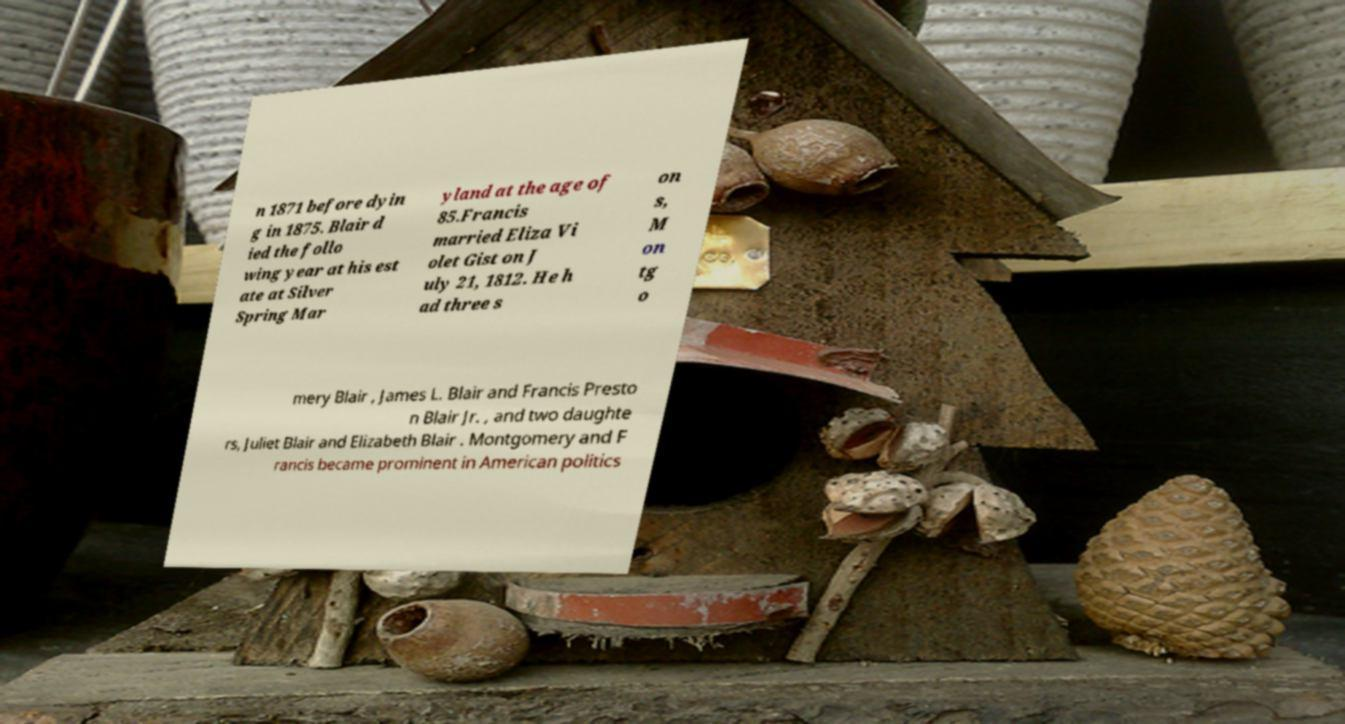Can you read and provide the text displayed in the image?This photo seems to have some interesting text. Can you extract and type it out for me? n 1871 before dyin g in 1875. Blair d ied the follo wing year at his est ate at Silver Spring Mar yland at the age of 85.Francis married Eliza Vi olet Gist on J uly 21, 1812. He h ad three s on s, M on tg o mery Blair , James L. Blair and Francis Presto n Blair Jr. , and two daughte rs, Juliet Blair and Elizabeth Blair . Montgomery and F rancis became prominent in American politics 